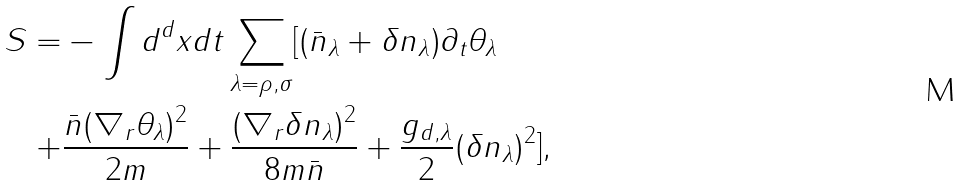<formula> <loc_0><loc_0><loc_500><loc_500>S = & - \int d ^ { d } x d t \sum _ { \lambda = \rho , \sigma } [ ( \bar { n } _ { \lambda } + \delta n _ { \lambda } ) \partial _ { t } \theta _ { \lambda } \\ + & \frac { \bar { n } ( \nabla _ { r } \theta _ { \lambda } ) ^ { 2 } } { 2 m } + \frac { ( \nabla _ { r } \delta n _ { \lambda } ) ^ { 2 } } { 8 m \bar { n } } + \frac { g _ { d , \lambda } } { 2 } ( \delta n _ { \lambda } ) ^ { 2 } ] ,</formula> 